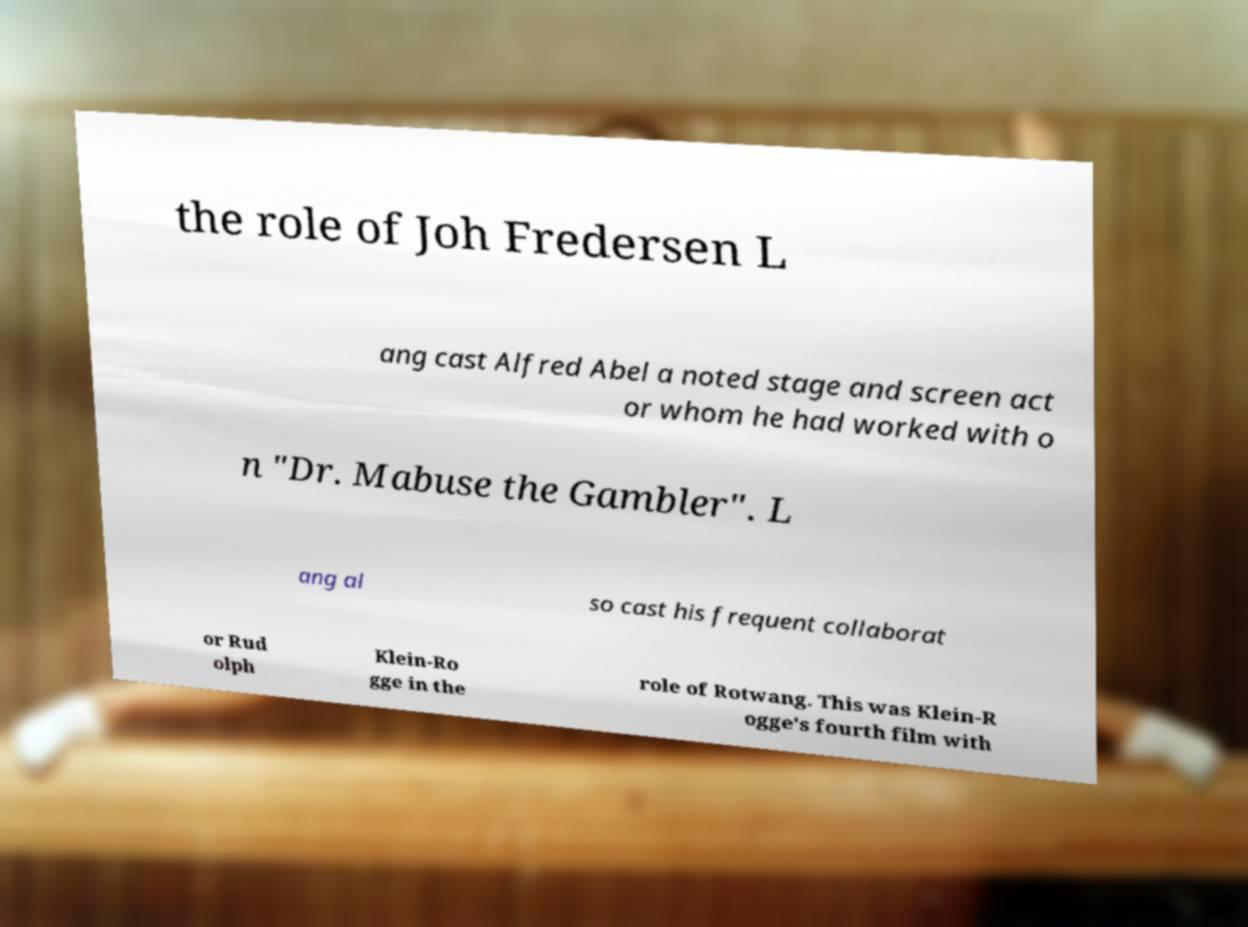For documentation purposes, I need the text within this image transcribed. Could you provide that? the role of Joh Fredersen L ang cast Alfred Abel a noted stage and screen act or whom he had worked with o n "Dr. Mabuse the Gambler". L ang al so cast his frequent collaborat or Rud olph Klein-Ro gge in the role of Rotwang. This was Klein-R ogge's fourth film with 